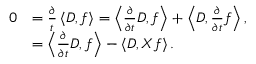<formula> <loc_0><loc_0><loc_500><loc_500>\begin{array} { r l } { 0 } & { = \frac { \partial } { t } \left \langle D , f \right \rangle = \left \langle \frac { \partial } { \partial t } D , f \right \rangle + \left \langle D , \frac { \partial } { \partial t } f \right \rangle , } \\ & { = \left \langle \frac { \partial } { \partial t } D , f \right \rangle - \left \langle D , X f \right \rangle . } \end{array}</formula> 